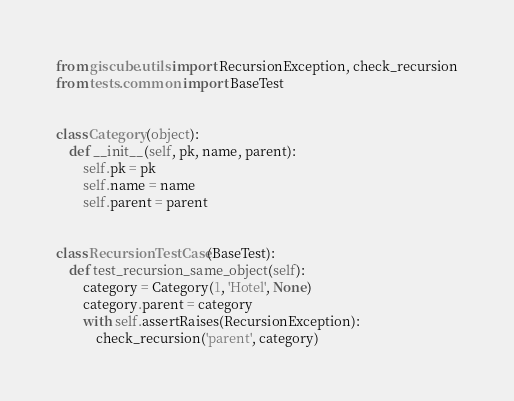Convert code to text. <code><loc_0><loc_0><loc_500><loc_500><_Python_>from giscube.utils import RecursionException, check_recursion
from tests.common import BaseTest


class Category(object):
    def __init__(self, pk, name, parent):
        self.pk = pk
        self.name = name
        self.parent = parent


class RecursionTestCase(BaseTest):
    def test_recursion_same_object(self):
        category = Category(1, 'Hotel', None)
        category.parent = category
        with self.assertRaises(RecursionException):
            check_recursion('parent', category)
</code> 